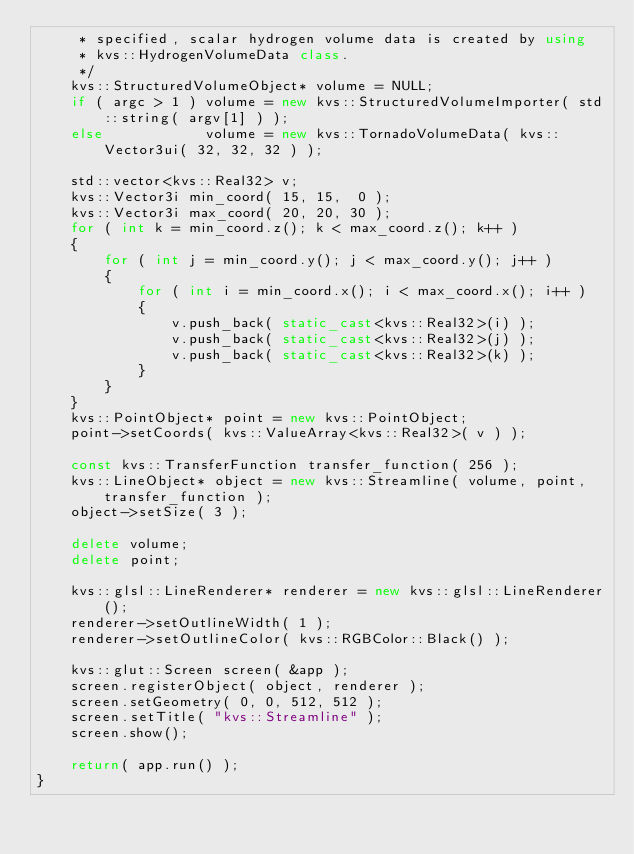<code> <loc_0><loc_0><loc_500><loc_500><_C++_>     * specified, scalar hydrogen volume data is created by using
     * kvs::HydrogenVolumeData class.
     */
    kvs::StructuredVolumeObject* volume = NULL;
    if ( argc > 1 ) volume = new kvs::StructuredVolumeImporter( std::string( argv[1] ) );
    else            volume = new kvs::TornadoVolumeData( kvs::Vector3ui( 32, 32, 32 ) );

    std::vector<kvs::Real32> v;
    kvs::Vector3i min_coord( 15, 15,  0 );
    kvs::Vector3i max_coord( 20, 20, 30 );
    for ( int k = min_coord.z(); k < max_coord.z(); k++ )
    {
        for ( int j = min_coord.y(); j < max_coord.y(); j++ )
        {
            for ( int i = min_coord.x(); i < max_coord.x(); i++ )
            {
                v.push_back( static_cast<kvs::Real32>(i) );
                v.push_back( static_cast<kvs::Real32>(j) );
                v.push_back( static_cast<kvs::Real32>(k) );
            }
        }
    }
    kvs::PointObject* point = new kvs::PointObject;
    point->setCoords( kvs::ValueArray<kvs::Real32>( v ) );

    const kvs::TransferFunction transfer_function( 256 );
    kvs::LineObject* object = new kvs::Streamline( volume, point, transfer_function );
    object->setSize( 3 );

    delete volume;
    delete point;

    kvs::glsl::LineRenderer* renderer = new kvs::glsl::LineRenderer();
    renderer->setOutlineWidth( 1 );
    renderer->setOutlineColor( kvs::RGBColor::Black() );

    kvs::glut::Screen screen( &app );
    screen.registerObject( object, renderer );
    screen.setGeometry( 0, 0, 512, 512 );
    screen.setTitle( "kvs::Streamline" );
    screen.show();

    return( app.run() );
}
</code> 